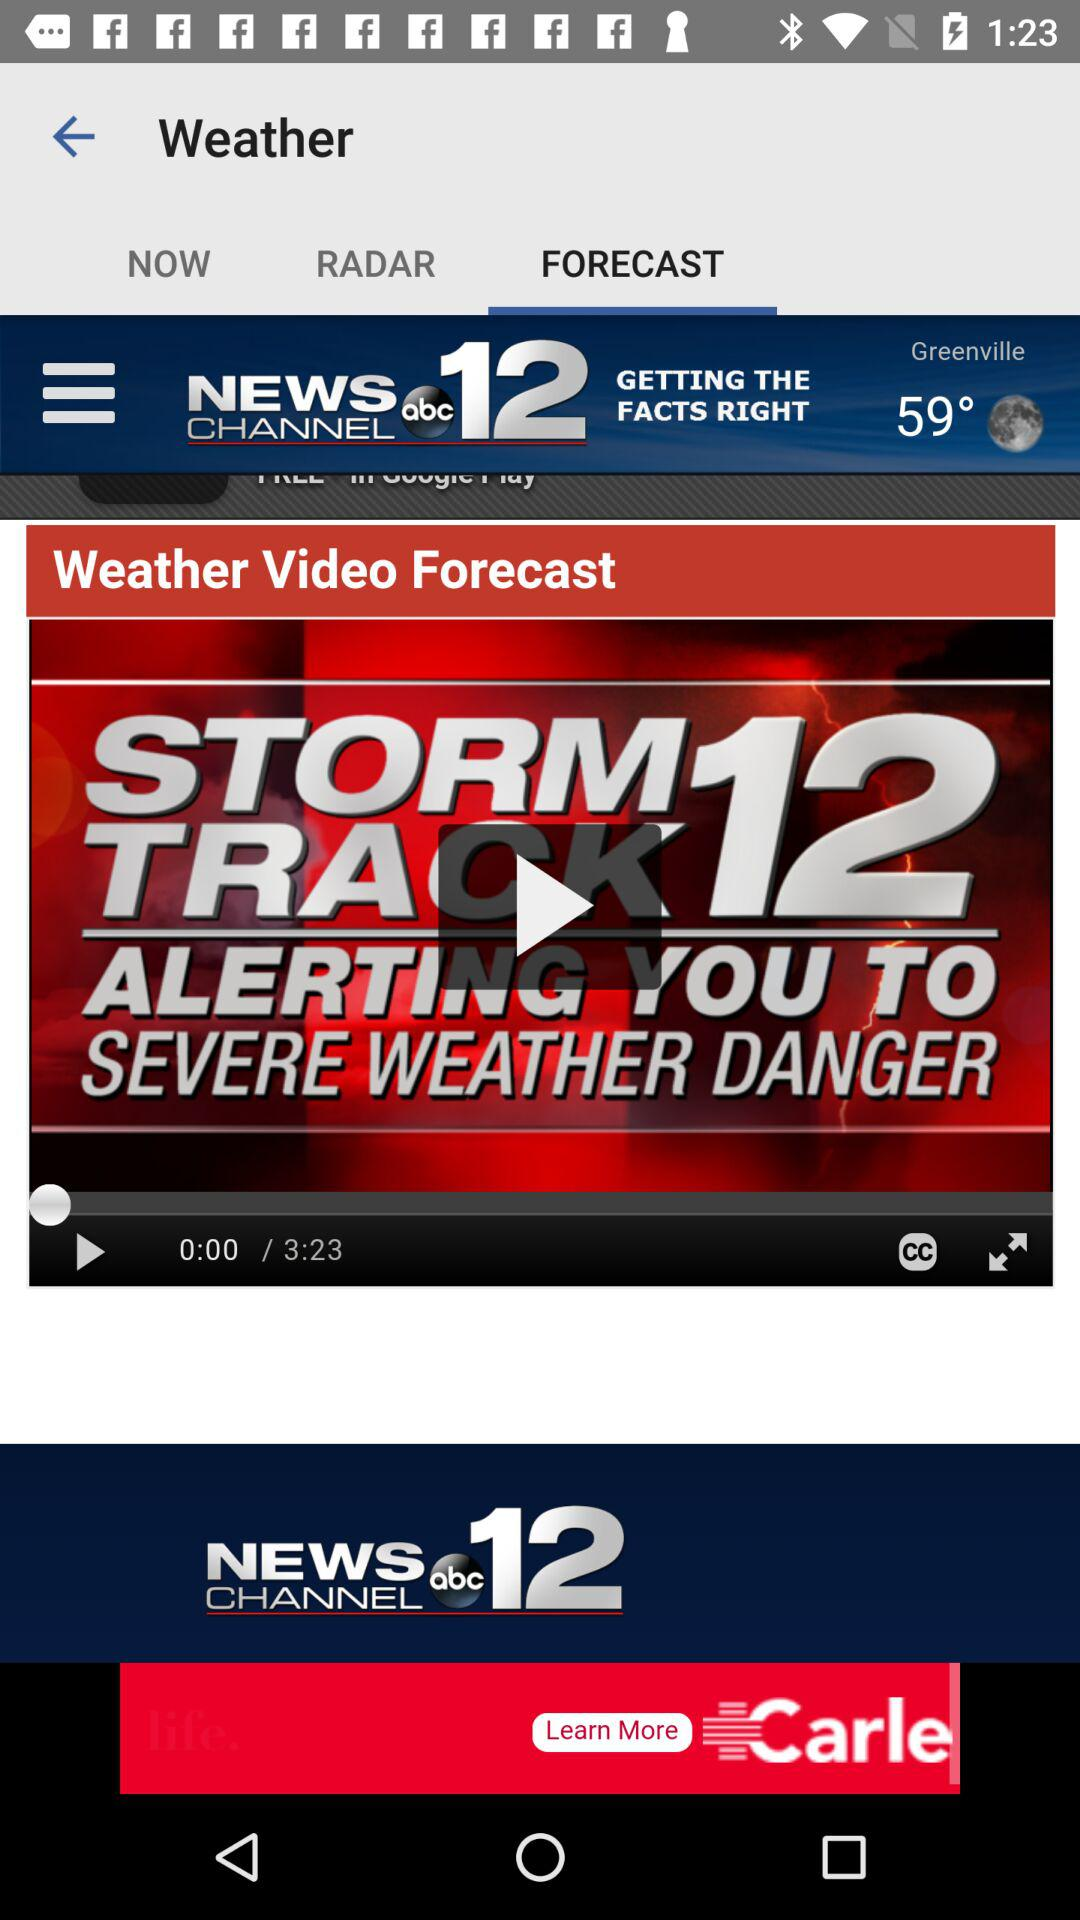Which tab is selected? The selected tab is "Forecast". 